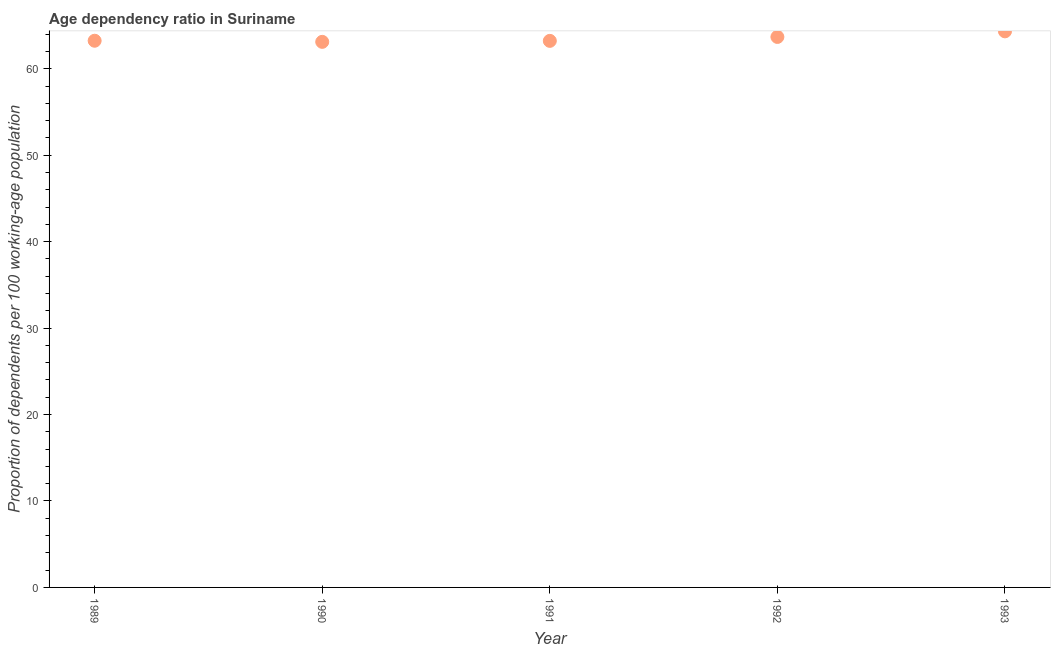What is the age dependency ratio in 1993?
Give a very brief answer. 64.34. Across all years, what is the maximum age dependency ratio?
Provide a succinct answer. 64.34. Across all years, what is the minimum age dependency ratio?
Your answer should be compact. 63.12. In which year was the age dependency ratio minimum?
Your response must be concise. 1990. What is the sum of the age dependency ratio?
Make the answer very short. 317.64. What is the difference between the age dependency ratio in 1990 and 1991?
Provide a short and direct response. -0.11. What is the average age dependency ratio per year?
Keep it short and to the point. 63.53. What is the median age dependency ratio?
Make the answer very short. 63.25. In how many years, is the age dependency ratio greater than 34 ?
Offer a terse response. 5. Do a majority of the years between 1991 and 1990 (inclusive) have age dependency ratio greater than 22 ?
Make the answer very short. No. What is the ratio of the age dependency ratio in 1990 to that in 1993?
Keep it short and to the point. 0.98. Is the age dependency ratio in 1991 less than that in 1993?
Offer a very short reply. Yes. Is the difference between the age dependency ratio in 1990 and 1992 greater than the difference between any two years?
Your answer should be compact. No. What is the difference between the highest and the second highest age dependency ratio?
Give a very brief answer. 0.65. Is the sum of the age dependency ratio in 1989 and 1992 greater than the maximum age dependency ratio across all years?
Offer a very short reply. Yes. What is the difference between the highest and the lowest age dependency ratio?
Offer a terse response. 1.22. In how many years, is the age dependency ratio greater than the average age dependency ratio taken over all years?
Make the answer very short. 2. Does the age dependency ratio monotonically increase over the years?
Keep it short and to the point. No. How many years are there in the graph?
Ensure brevity in your answer.  5. Does the graph contain any zero values?
Keep it short and to the point. No. Does the graph contain grids?
Offer a terse response. No. What is the title of the graph?
Offer a terse response. Age dependency ratio in Suriname. What is the label or title of the X-axis?
Offer a terse response. Year. What is the label or title of the Y-axis?
Make the answer very short. Proportion of dependents per 100 working-age population. What is the Proportion of dependents per 100 working-age population in 1989?
Keep it short and to the point. 63.25. What is the Proportion of dependents per 100 working-age population in 1990?
Give a very brief answer. 63.12. What is the Proportion of dependents per 100 working-age population in 1991?
Your answer should be compact. 63.24. What is the Proportion of dependents per 100 working-age population in 1992?
Offer a terse response. 63.69. What is the Proportion of dependents per 100 working-age population in 1993?
Offer a very short reply. 64.34. What is the difference between the Proportion of dependents per 100 working-age population in 1989 and 1990?
Provide a short and direct response. 0.13. What is the difference between the Proportion of dependents per 100 working-age population in 1989 and 1991?
Provide a succinct answer. 0.02. What is the difference between the Proportion of dependents per 100 working-age population in 1989 and 1992?
Keep it short and to the point. -0.44. What is the difference between the Proportion of dependents per 100 working-age population in 1989 and 1993?
Your answer should be compact. -1.09. What is the difference between the Proportion of dependents per 100 working-age population in 1990 and 1991?
Make the answer very short. -0.11. What is the difference between the Proportion of dependents per 100 working-age population in 1990 and 1992?
Give a very brief answer. -0.57. What is the difference between the Proportion of dependents per 100 working-age population in 1990 and 1993?
Provide a succinct answer. -1.22. What is the difference between the Proportion of dependents per 100 working-age population in 1991 and 1992?
Make the answer very short. -0.45. What is the difference between the Proportion of dependents per 100 working-age population in 1991 and 1993?
Provide a succinct answer. -1.1. What is the difference between the Proportion of dependents per 100 working-age population in 1992 and 1993?
Your response must be concise. -0.65. What is the ratio of the Proportion of dependents per 100 working-age population in 1989 to that in 1991?
Provide a succinct answer. 1. What is the ratio of the Proportion of dependents per 100 working-age population in 1990 to that in 1991?
Your answer should be very brief. 1. What is the ratio of the Proportion of dependents per 100 working-age population in 1992 to that in 1993?
Your answer should be compact. 0.99. 